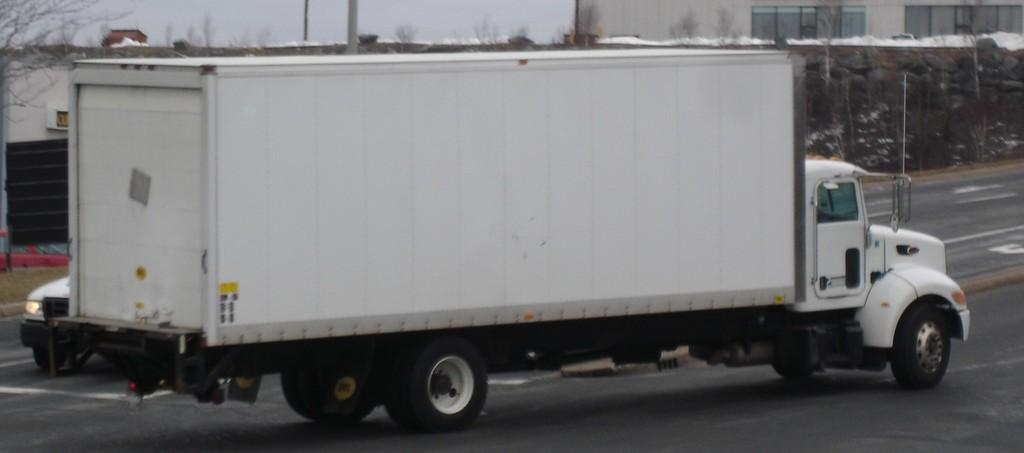What type of vehicle is present in the image? There is a truck in the image. Are there any other vehicles in the image? Yes, there is a car in the image. Where are the truck and car located? Both the truck and car are on the road. What can be seen in the background of the image? There are trees and buildings in the background of the image. What type of wren is perched on the car in the image? There is no wren present in the image; it only features a truck and a car. What color are the trousers worn by the man in the image? There is no man present in the image, so it is not possible to determine the color of any trousers. 